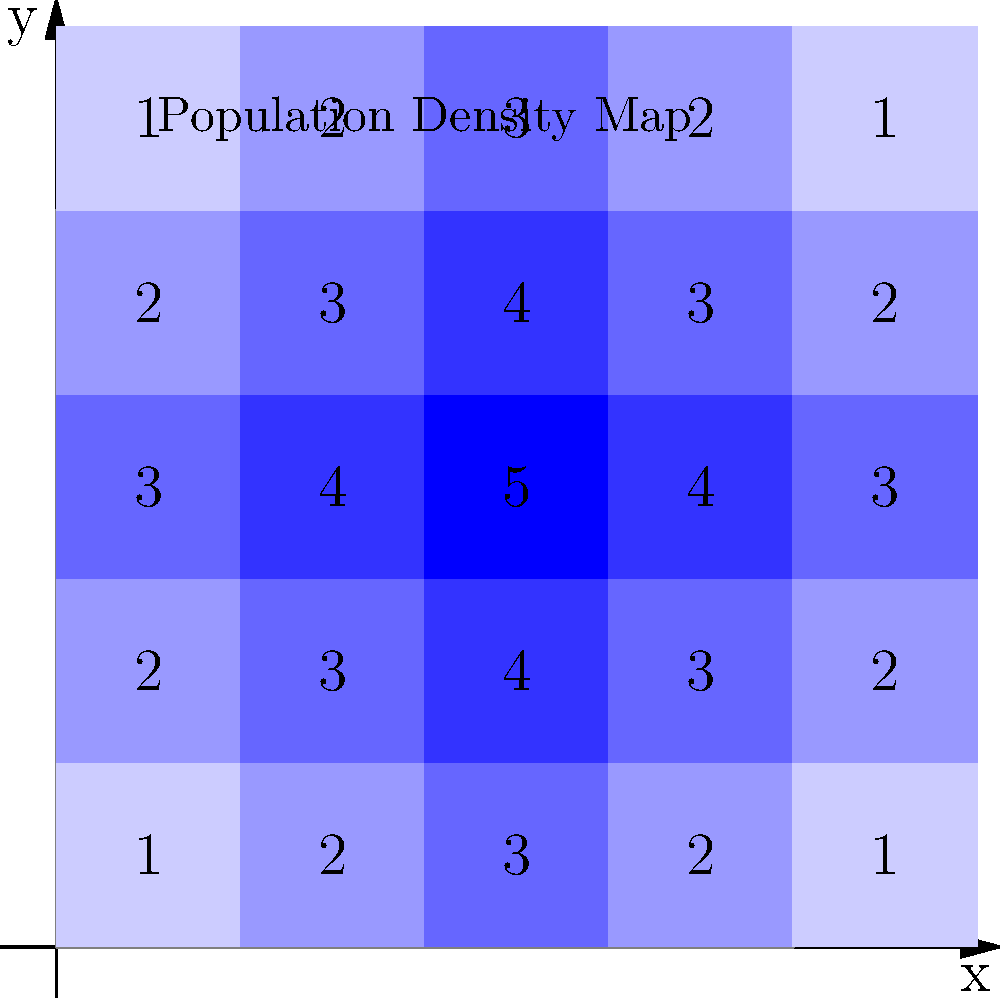Given the zoning map with population density indicators (where higher numbers represent higher density), determine the optimal location for a community health center that would serve the most people while considering accessibility. What are the coordinates (x, y) of the best location? To determine the optimal location for a community health center, we need to consider both population density and accessibility. Let's approach this step-by-step:

1. Identify the highest density areas:
   The center of the map (2,2) has the highest density of 5.

2. Consider surrounding areas:
   The cells adjacent to (2,2) have densities of 4, forming a cross pattern.

3. Evaluate accessibility:
   While (2,2) has the highest density, placing the center there might make it less accessible to people in the outer regions.

4. Calculate weighted average:
   For each cell, we can calculate a weighted average considering its own density and the densities of adjacent cells.

   For example, for cell (2,2):
   Weight = 5 + (4+4+4+4)/2 = 13

   For cell (1,2) or (3,2):
   Weight = 4 + (3+4+5+3)/2 = 11.5

5. Consider central location:
   Among the high-density areas, (2,2) is the most central, making it equally accessible from all directions.

6. Balance density and accessibility:
   While cells like (1,2) or (3,2) have good density and are closer to some lower-density areas, (2,2) provides the best balance of high density and central location.

Therefore, the optimal location for the community health center would be at coordinates (2,2).
Answer: (2,2) 